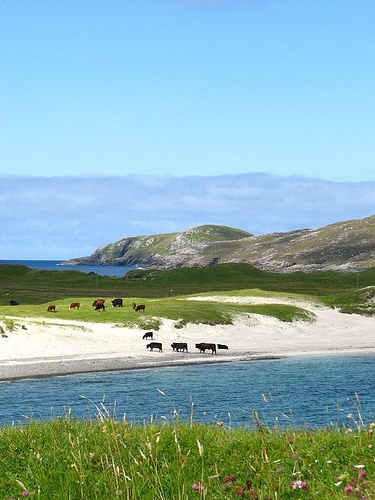Describe the objects in this image and their specific colors. I can see cow in lightblue, black, darkgray, and gray tones, cow in lightblue, black, gray, white, and darkgray tones, cow in lightblue, black, white, darkgray, and gray tones, cow in lightblue, black, darkgreen, and gray tones, and cow in lightblue, black, white, gray, and darkgray tones in this image. 